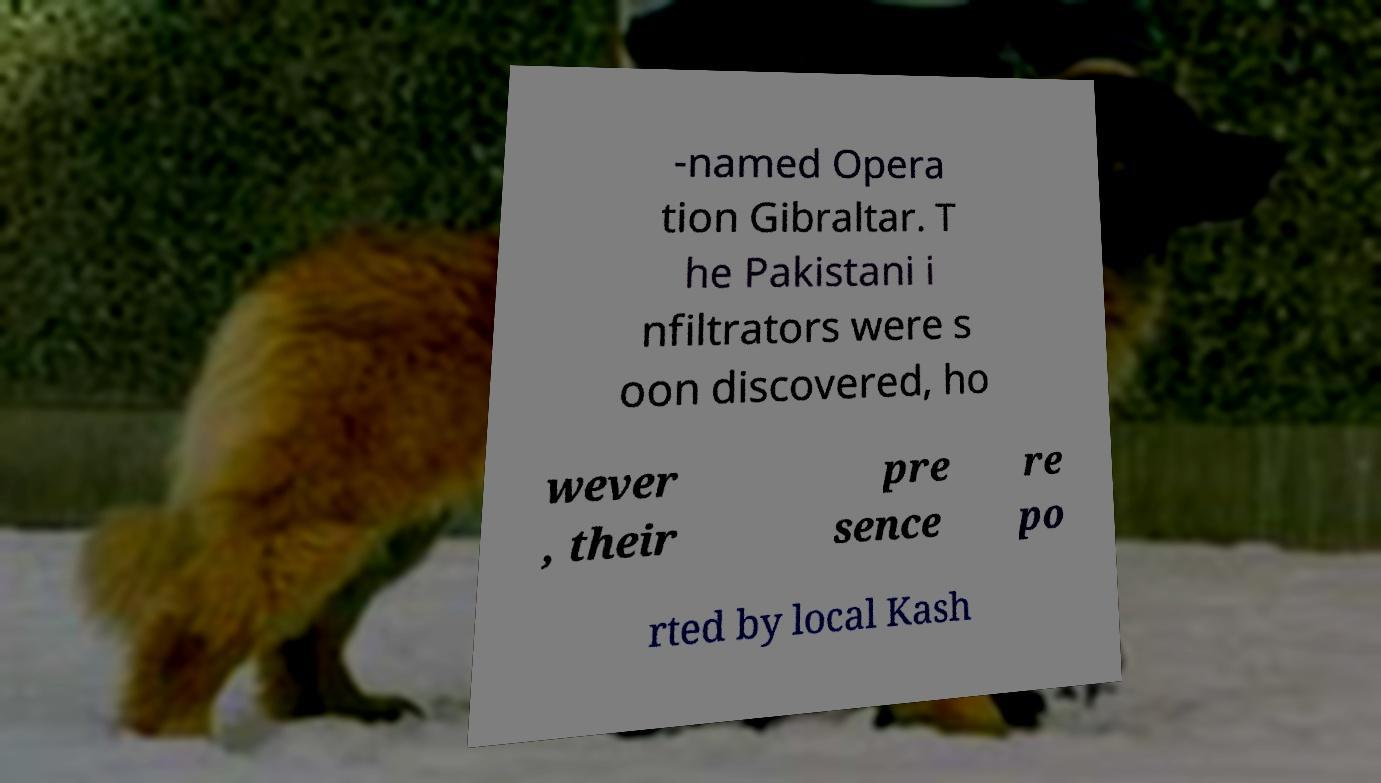There's text embedded in this image that I need extracted. Can you transcribe it verbatim? -named Opera tion Gibraltar. T he Pakistani i nfiltrators were s oon discovered, ho wever , their pre sence re po rted by local Kash 